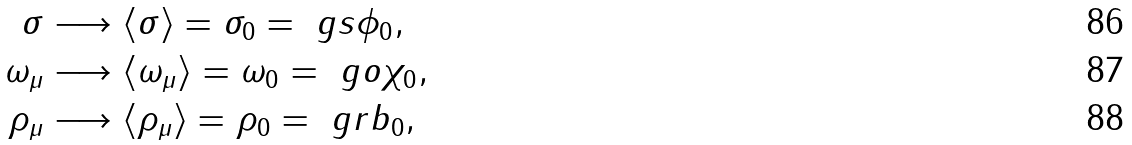<formula> <loc_0><loc_0><loc_500><loc_500>\sigma & \longrightarrow \langle \sigma \rangle = \sigma _ { 0 } = \ g s \phi _ { 0 } , \\ \omega _ { \mu } & \longrightarrow \langle \omega _ { \mu } \rangle = \omega _ { 0 } = \ g o \chi _ { 0 } , \\ \rho _ { \mu } & \longrightarrow \langle \rho _ { \mu } \rangle = \rho _ { 0 } = \ g r b _ { 0 } ,</formula> 